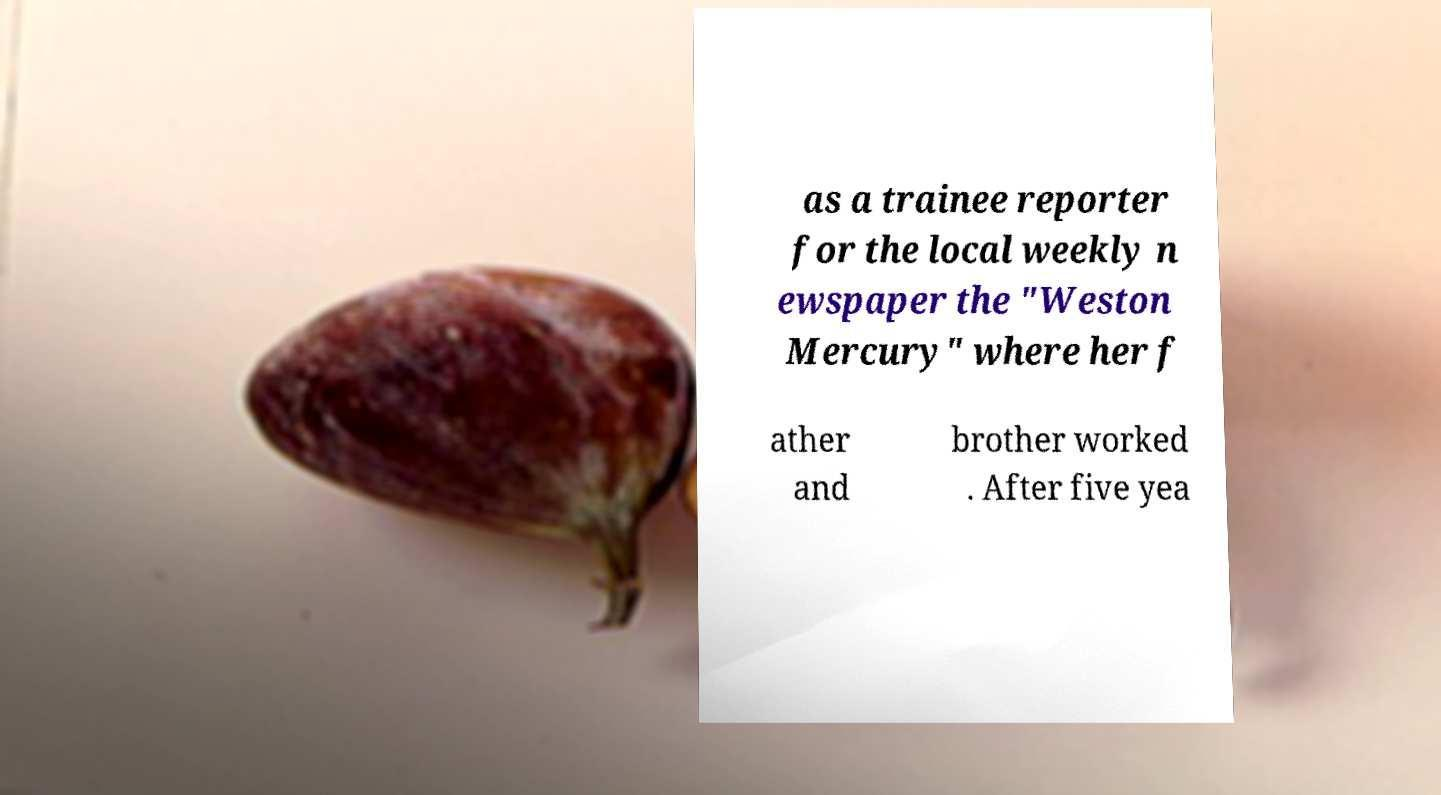What messages or text are displayed in this image? I need them in a readable, typed format. as a trainee reporter for the local weekly n ewspaper the "Weston Mercury" where her f ather and brother worked . After five yea 